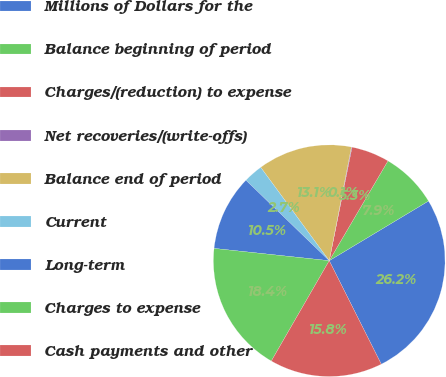Convert chart to OTSL. <chart><loc_0><loc_0><loc_500><loc_500><pie_chart><fcel>Millions of Dollars for the<fcel>Balance beginning of period<fcel>Charges/(reduction) to expense<fcel>Net recoveries/(write-offs)<fcel>Balance end of period<fcel>Current<fcel>Long-term<fcel>Charges to expense<fcel>Cash payments and other<nl><fcel>26.19%<fcel>7.92%<fcel>5.31%<fcel>0.09%<fcel>13.14%<fcel>2.7%<fcel>10.53%<fcel>18.36%<fcel>15.75%<nl></chart> 